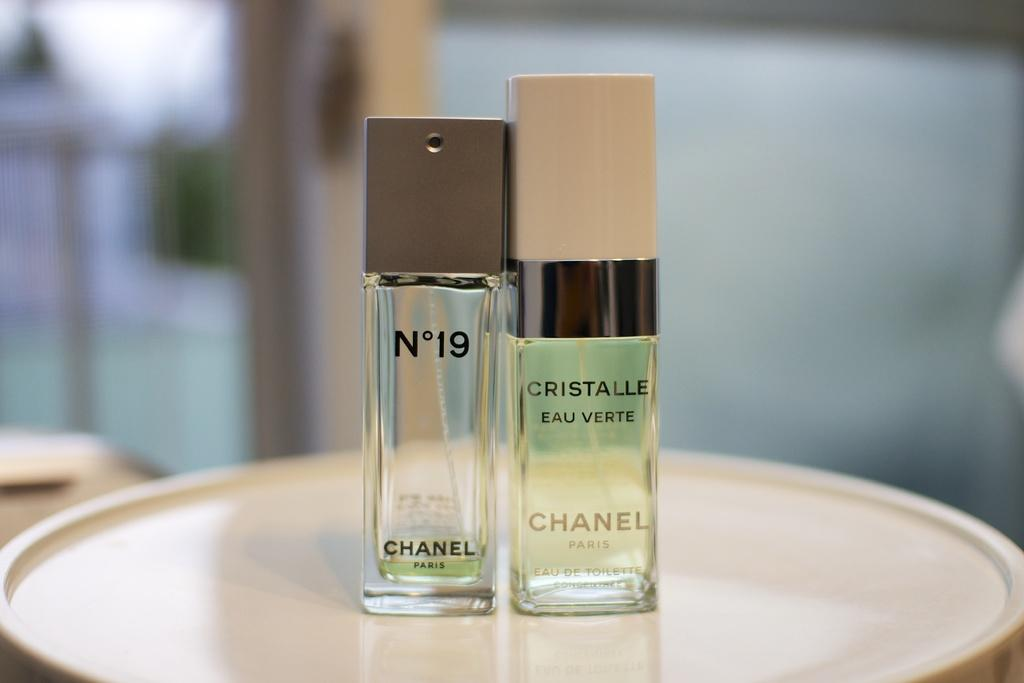<image>
Write a terse but informative summary of the picture. Two bottles of Chanel perfume bottles sitting on a platter. 